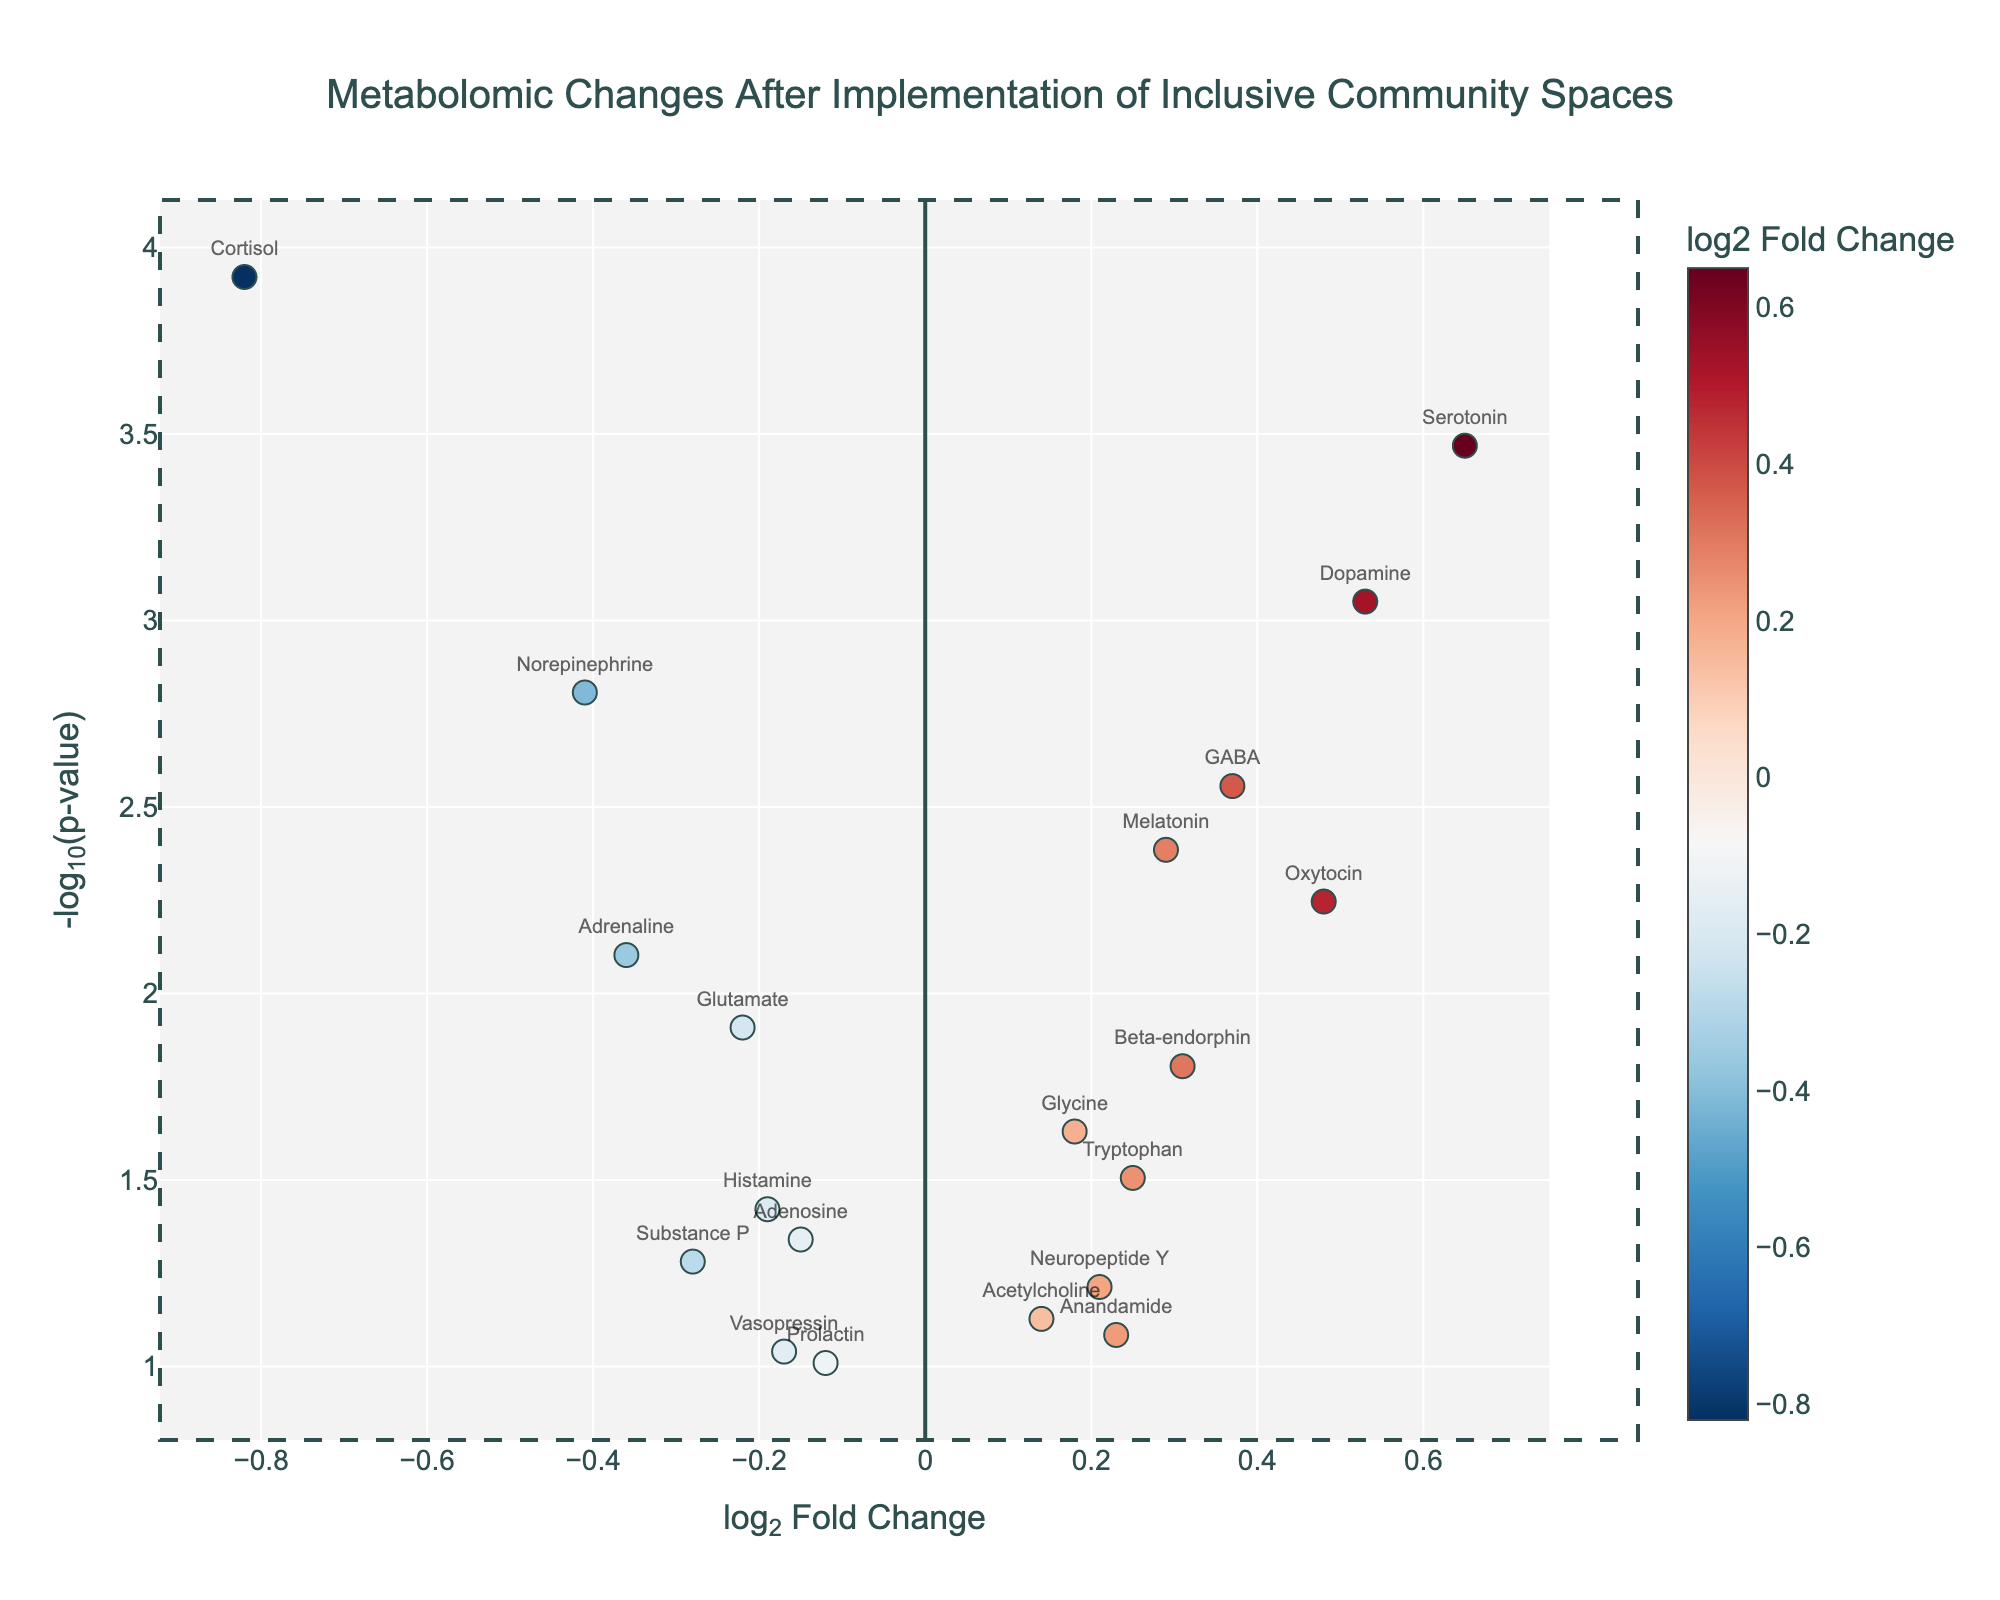How many metabolites showed a significant p-value of less than 0.05? By observing the horizontal dashed line, which represents the threshold of a p-value of 0.05 (-log10(0.05)), we can count the number of points above this line.
Answer: 13 Which metabolite has the highest log2 fold change? By examining the plot for the data point with the largest positive log2 fold change on the x-axis, we can identify it as Serotonin.
Answer: Serotonin Are there any metabolites with a negative log2 fold change and a significant p-value? To find metabolites with a negative log2 fold change, look for points left of the centerline (0 log2FC). Then, check if these points are above the horizontal dashed line representing significant p-values. Cortisol, Norepinephrine, Adrenaline, and Glutamate meet these criteria.
Answer: Yes Which metabolite has the lowest p-value? The lowest p-value will correspond to the point positioned highest on the y-axis. This is Cortisol.
Answer: Cortisol What is the log2 fold change and p-value of Dopamine? By locating Dopamine on the plot and checking its x (log2FC) and y (-log10(p-value)) coordinates through the hover text: log2FC is around 0.53, and p-value is approximately 0.00089, which gives us -log10(p-value) close to 3.05.
Answer: log2FC: 0.53, p-value: 0.00089 Which metabolites showed an increase after the implementation of inclusive community spaces? Metabolites with positive log2 fold changes (right of the centerline) indicate an increase. These are Serotonin, Dopamine, GABA, Melatonin, Oxytocin, Beta-endorphin, Glycine, Tryptophan, Neuropeptide Y, Acetylcholine, and Anandamide.
Answer: Serotonin, Dopamine, GABA, Melatonin, Oxytocin, Beta-endorphin, Glycine, Tryptophan, Neuropeptide Y, Acetylcholine, Anandamide What is a unique feature of a Volcano Plot that helps interpret significance and effect size simultaneously? A Volcano Plot uniquely displays both the statistical significance (-log10(p-value) on the y-axis) and the magnitude of change (log2 fold change on the x-axis) simultaneously, allowing for an easy identification of noteworthy changes.
Answer: Displays significance and effect size Considering the significant biomarkers, how many showed a decrease in log2 fold change? Significant biomarkers have points above the horizontal dashed line. Among these, those to the left of the centerline (negative log2 fold change) showed a decrease: Cortisol, Norepinephrine, Adrenaline, and Glutamate.
Answer: 4 Which biomarkers have log2 fold changes between -0.5 and 0.5 but are still significant? Focus on the region between the dashed vertical lines at -0.5 and 0.5 log2 fold change. Among these, the higher points above the horizontal significance threshold are GABA, Melatonin, Oxytocin, Beta-endorphin, Glycine, Tryptophan, Histamine, and Adenosine.
Answer: GABA, Melatonin, Oxytocin, Beta-endorphin, Glycine, Tryptophan, Histamine, Adenosine Which biomarker shows the smallest log2 fold change but still has a significant p-value? Look for the point closest to the y-axis (smallest absolute log2 fold change) that is above the horizontal significance threshold. This is Adenosine.
Answer: Adenosine 